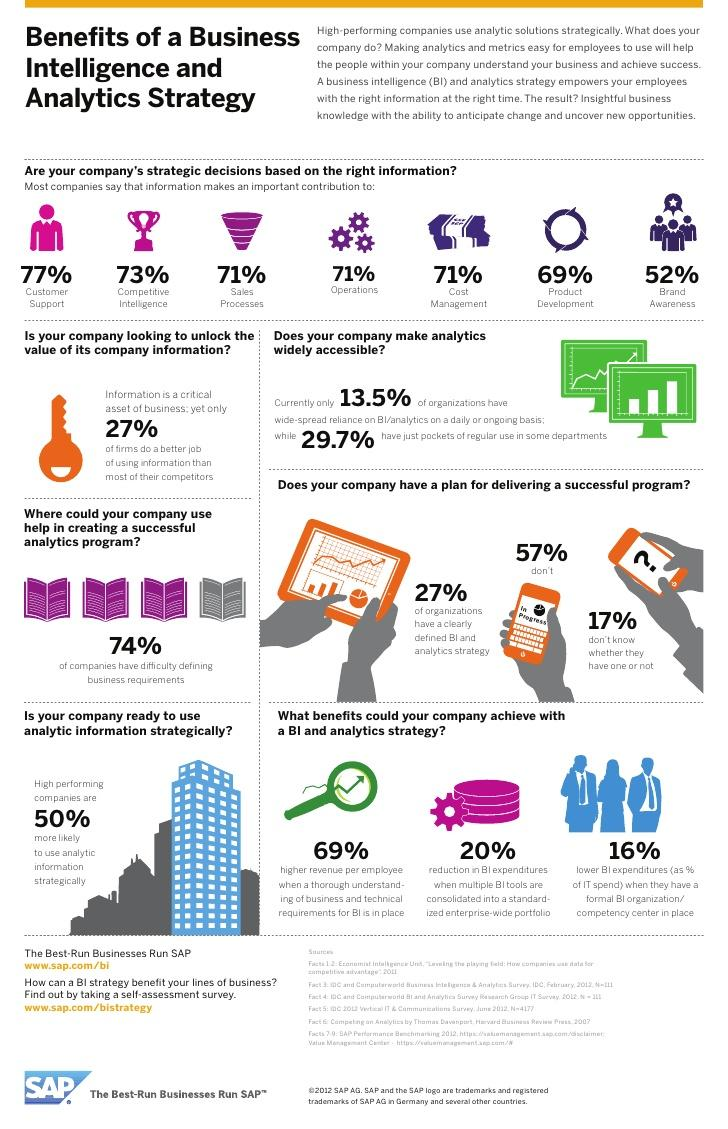Indicate a few pertinent items in this graphic. A significant percentage of companies, at 74%, face challenges in clearly defining their business requirements. According to a survey of companies, 71% believe that information is useful for their operations. The orange mobile phone displayed '57%' in progress on its display. Approximately 13.5% of organizations rely heavily on Business Intelligence for their daily operations. According to a survey, only 27% of organizations have a clearly defined business intelligence and analytics strategy. 